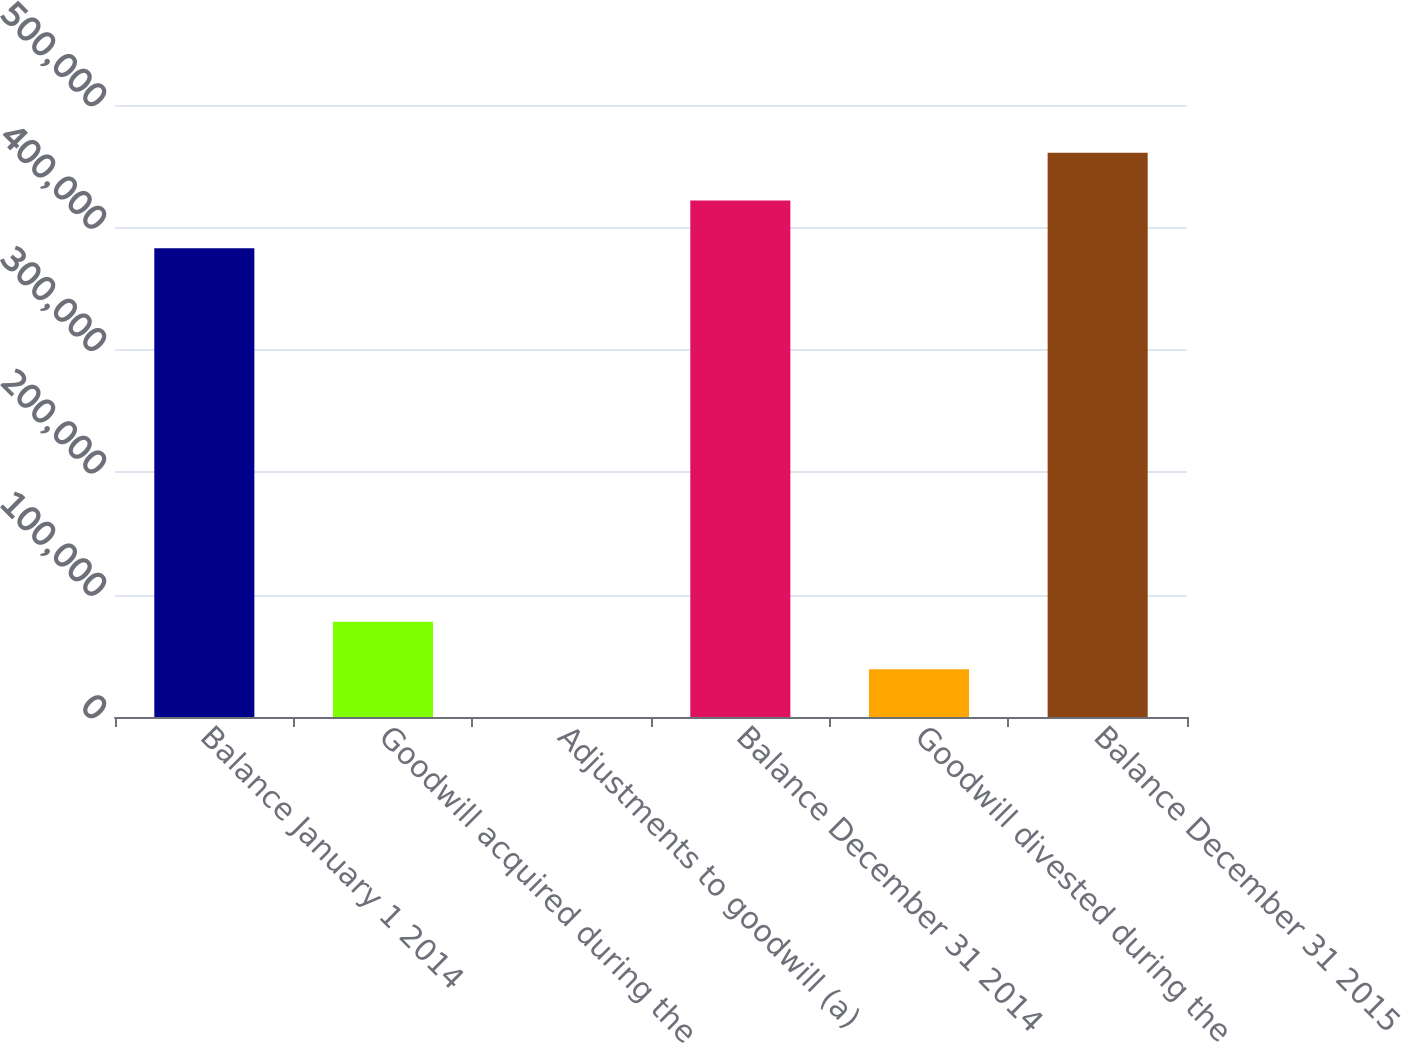Convert chart to OTSL. <chart><loc_0><loc_0><loc_500><loc_500><bar_chart><fcel>Balance January 1 2014<fcel>Goodwill acquired during the<fcel>Adjustments to goodwill (a)<fcel>Balance December 31 2014<fcel>Goodwill divested during the<fcel>Balance December 31 2015<nl><fcel>383011<fcel>77902.1<fcel>0.91<fcel>421962<fcel>38951.5<fcel>460912<nl></chart> 